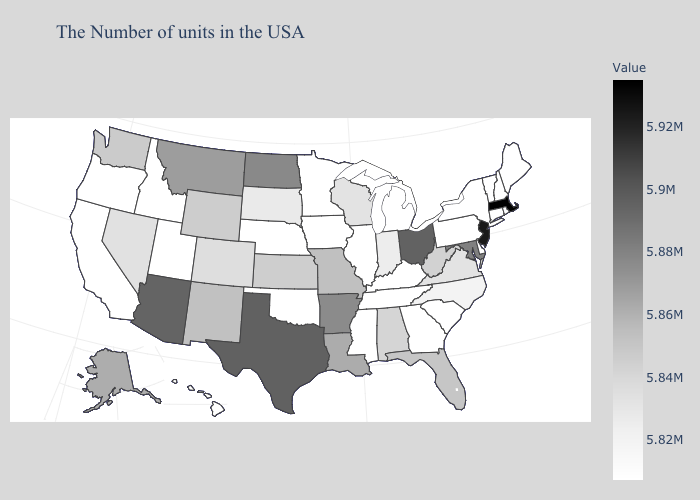Does Oregon have the highest value in the USA?
Answer briefly. No. Among the states that border Delaware , does Pennsylvania have the highest value?
Answer briefly. No. Among the states that border Alabama , which have the highest value?
Short answer required. Florida. Does Massachusetts have the highest value in the USA?
Write a very short answer. Yes. 